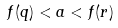<formula> <loc_0><loc_0><loc_500><loc_500>f ( q ) < a < f ( r )</formula> 